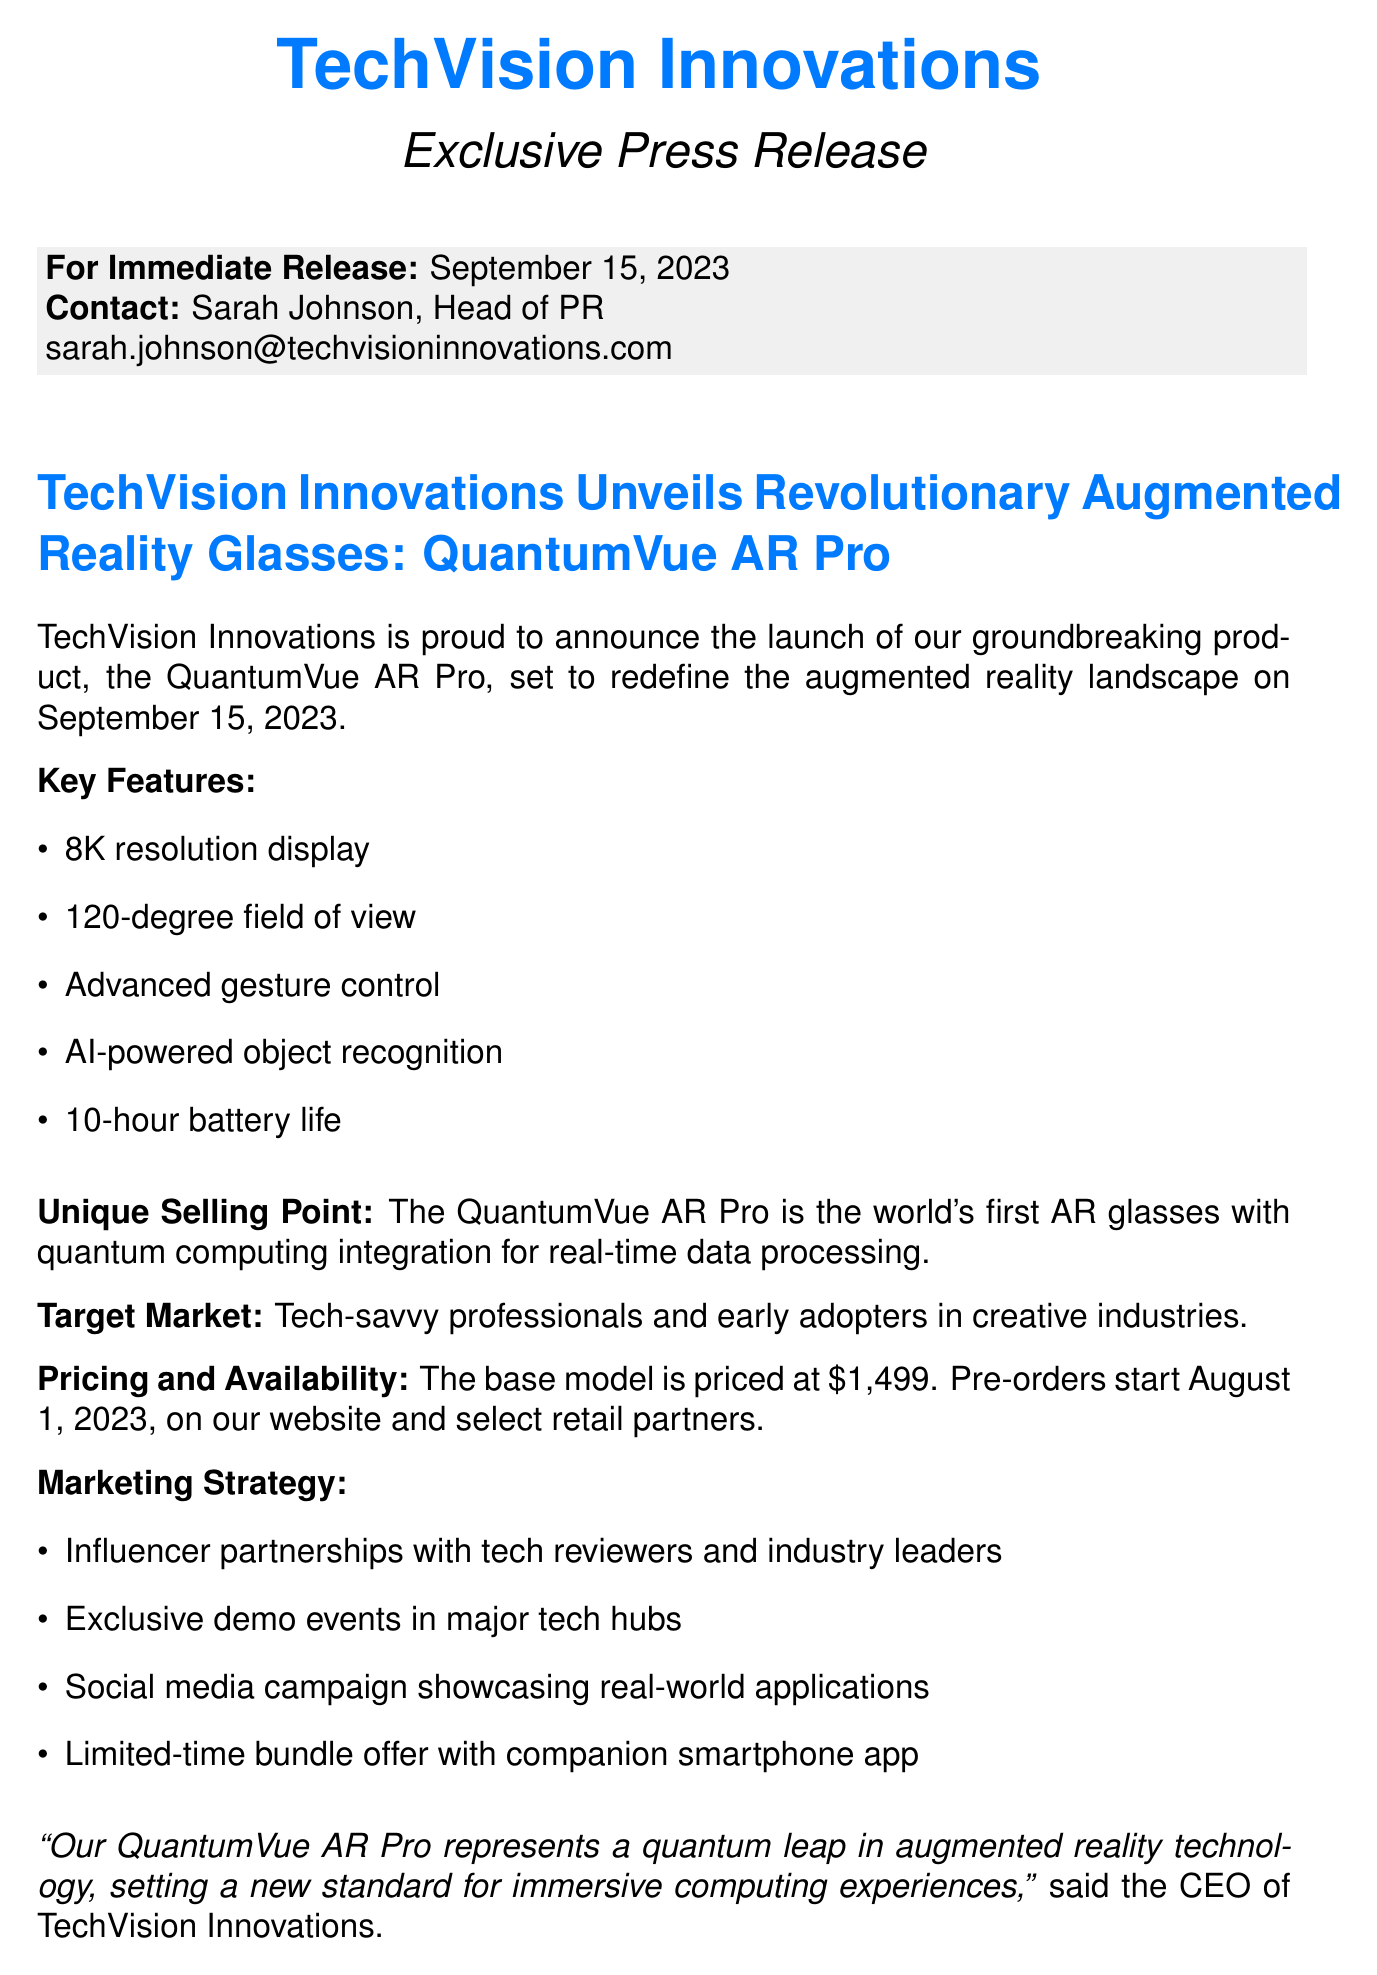What is the product name? The product name is stated as QuantumVue AR Pro.
Answer: QuantumVue AR Pro When is the release date? The release date is explicitly mentioned in the document as September 15, 2023.
Answer: September 15, 2023 What is the unique selling point of the product? The unique selling point highlights the key feature that differentiates it from competitors, which is quantum computing integration.
Answer: World's first AR glasses with quantum computing integration for real-time data processing What is the target market for the QuantumVue AR Pro? The document specifies that the target audience consists of tech-savvy professionals and early adopters in creative industries.
Answer: Tech-savvy professionals and early adopters in creative industries What is the price of the base model? The document clearly states that the base model is priced at $1,499.
Answer: $1,499 How long is the battery life? Battery life is one of the key features mentioned and it states the duration clearly.
Answer: 10-hour battery life What marketing strategy involves influencers? One of the described marketing strategies details partnerships with influencers.
Answer: Influencer partnerships with tech reviewers and industry leaders Who is the press contact for this release? The press contact's name and position are clearly outlined in the document as Sarah Johnson, Head of PR.
Answer: Sarah Johnson, Head of PR What is planned for Q2 2024? The future roadmap includes specific plans mentioned, which are integration and expansion.
Answer: Integration with smart home devices and expansion into enterprise solutions planned for Q2 2024 